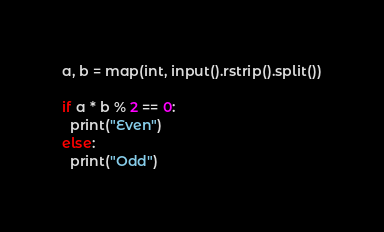Convert code to text. <code><loc_0><loc_0><loc_500><loc_500><_Python_>a, b = map(int, input().rstrip().split())

if a * b % 2 == 0:
  print("Even")
else:
  print("Odd")</code> 